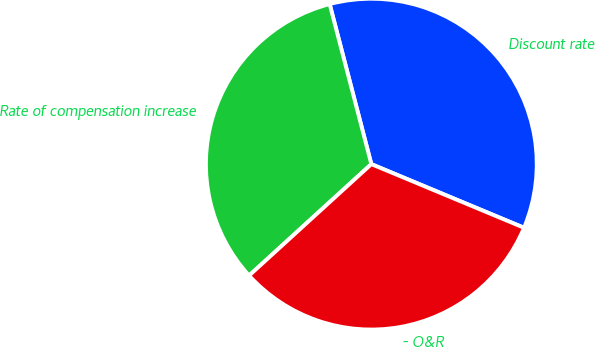Convert chart. <chart><loc_0><loc_0><loc_500><loc_500><pie_chart><fcel>Discount rate<fcel>Rate of compensation increase<fcel>- O&R<nl><fcel>35.34%<fcel>32.71%<fcel>31.95%<nl></chart> 